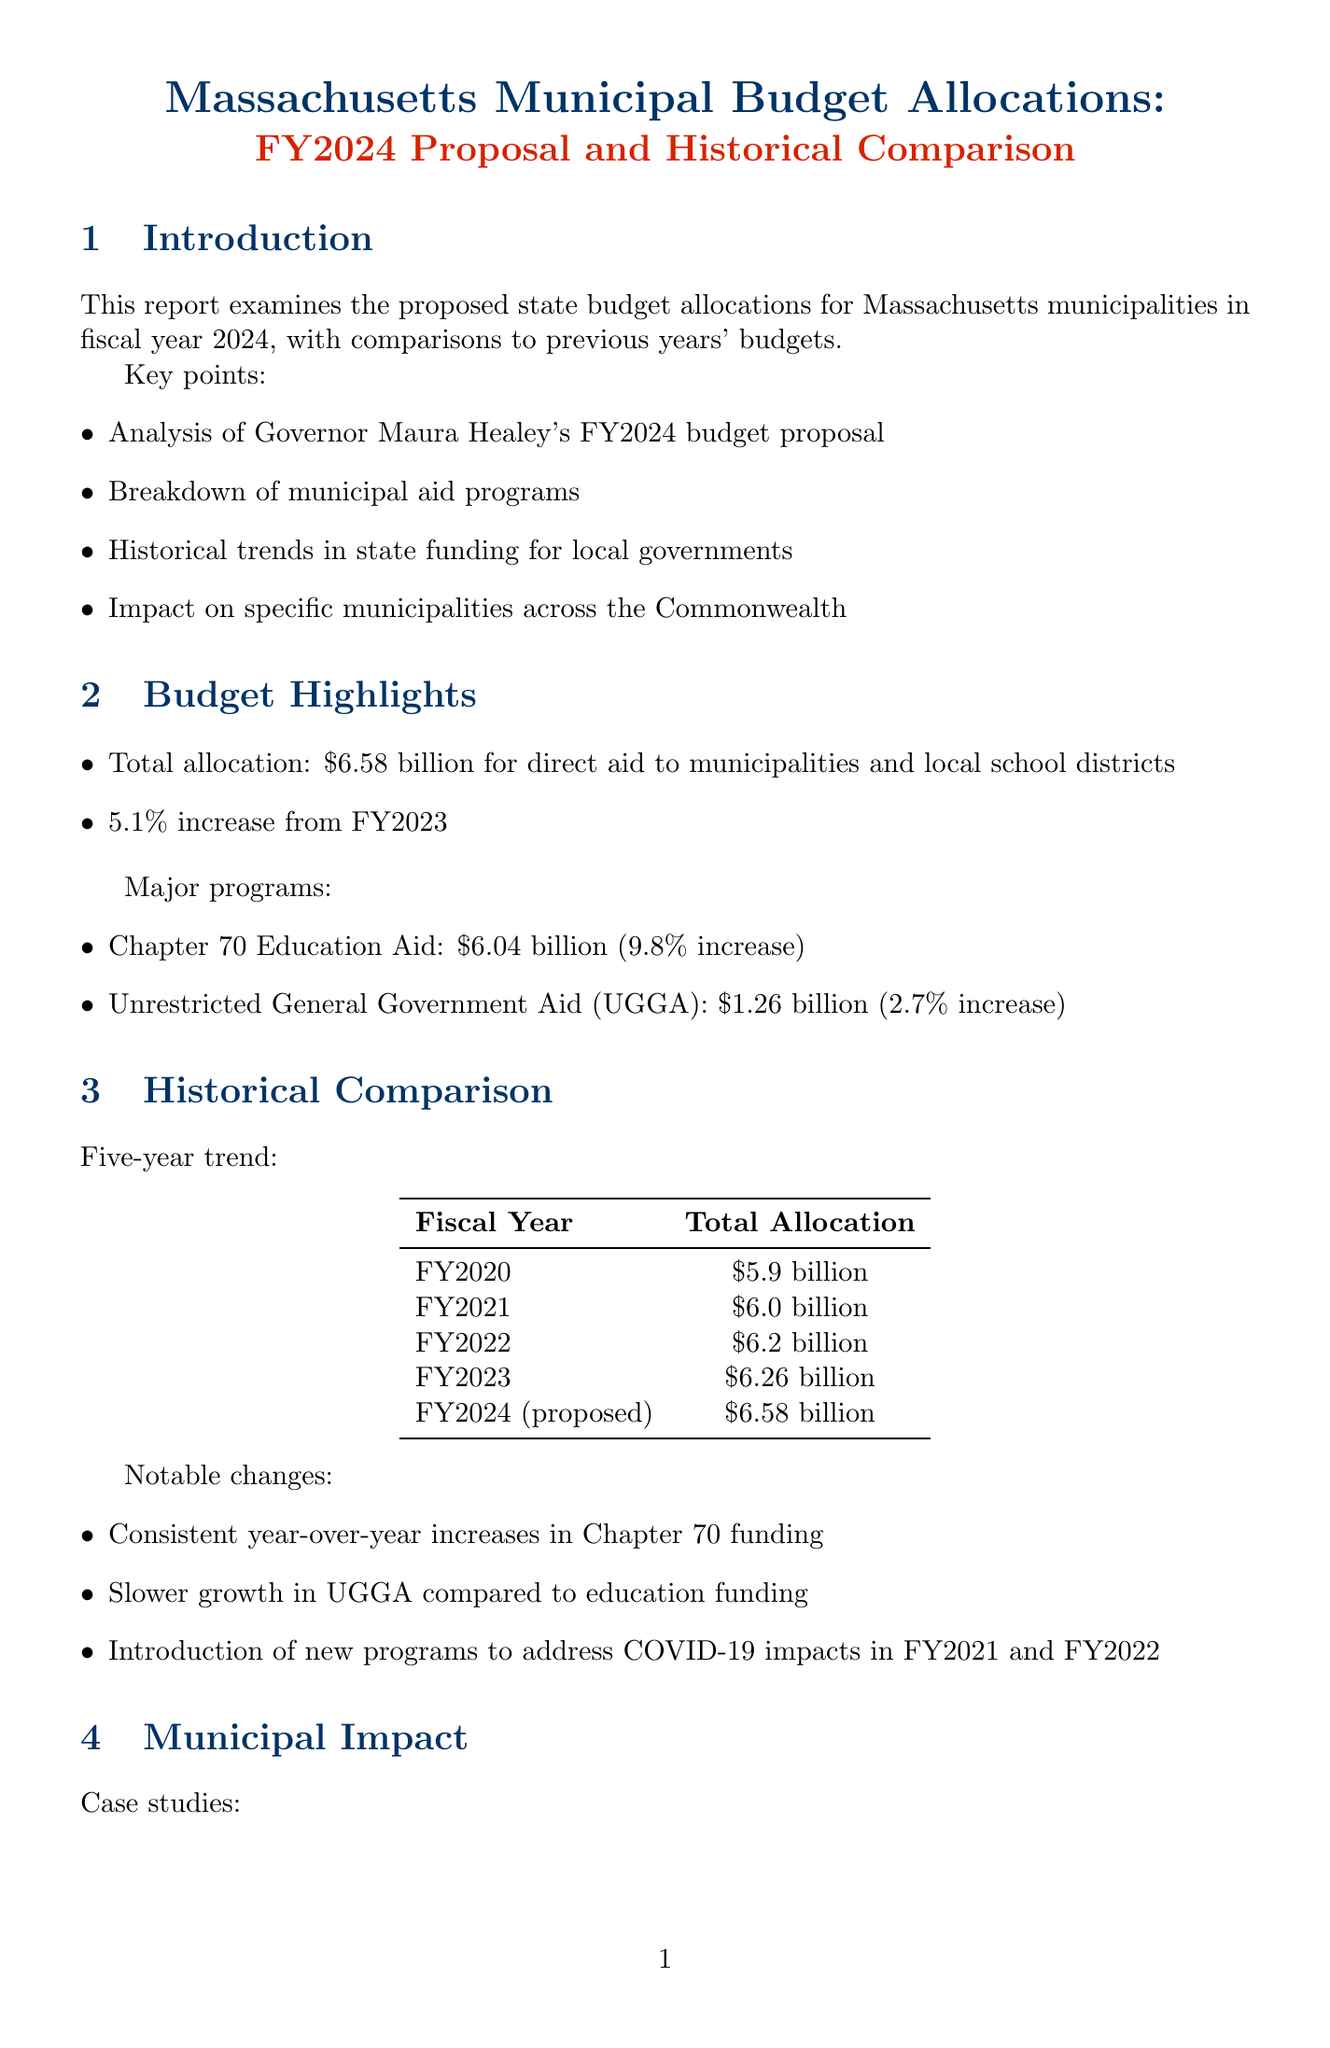What is the total allocation proposed for FY2024? The total allocation for FY2024 proposed in the document is clearly stated as $6.58 billion for direct aid to municipalities and local school districts.
Answer: $6.58 billion What percentage increase does the FY2024 budget show from FY2023? The document mentions a specific percentage increase from FY2023 to FY2024, which is highlighted as a 5.1% increase.
Answer: 5.1% Which program received the highest allocation in FY2024? By analyzing the budget highlights, the program with the highest allocation is identified, which is Chapter 70 Education Aid at $6.04 billion.
Answer: Chapter 70 Education Aid How much did Boston's allocation change from FY2023? The document provides the change in Boston's allocation from FY2023, which is referred to as a +4.2% change from the previous fiscal year.
Answer: +4.2% What was the allocation for Charter School Reimbursement in FY2024? The specific allocation for the Charter School Reimbursement program in FY2024 is detailed in the specific program analysis section of the document.
Answer: $243 million What is the target date for final budget approval? A notable key date mentioned in the legislative process section indicates the target date for final budget approval, which is clearly stated.
Answer: July 1, 2023 Which committee's budget proposal was presented on April 12, 2023? The legislative process section specifies that the House Ways and Means Committee presented their budget on this date.
Answer: House Ways and Means Committee What notable change occurred in UGGA funding compared to education funding? The document states a notable observation about UGGA funding growth rates compared to education funding, emphasizing its slower growth.
Answer: Slower growth 